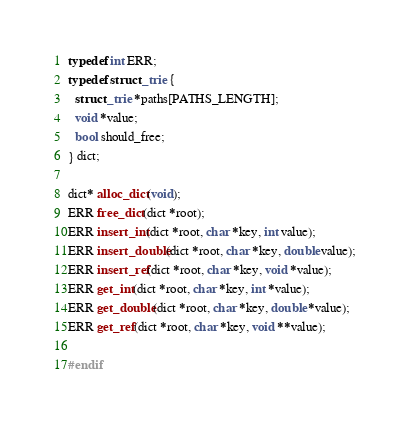Convert code to text. <code><loc_0><loc_0><loc_500><loc_500><_C_>typedef int ERR;
typedef struct _trie {
  struct _trie *paths[PATHS_LENGTH];
  void *value;
  bool should_free;
} dict;

dict* alloc_dict(void);
ERR free_dict(dict *root);
ERR insert_int(dict *root, char *key, int value);
ERR insert_double(dict *root, char *key, double value);
ERR insert_ref(dict *root, char *key, void *value);
ERR get_int(dict *root, char *key, int *value);
ERR get_double(dict *root, char *key, double *value);
ERR get_ref(dict *root, char *key, void **value);

#endif</code> 